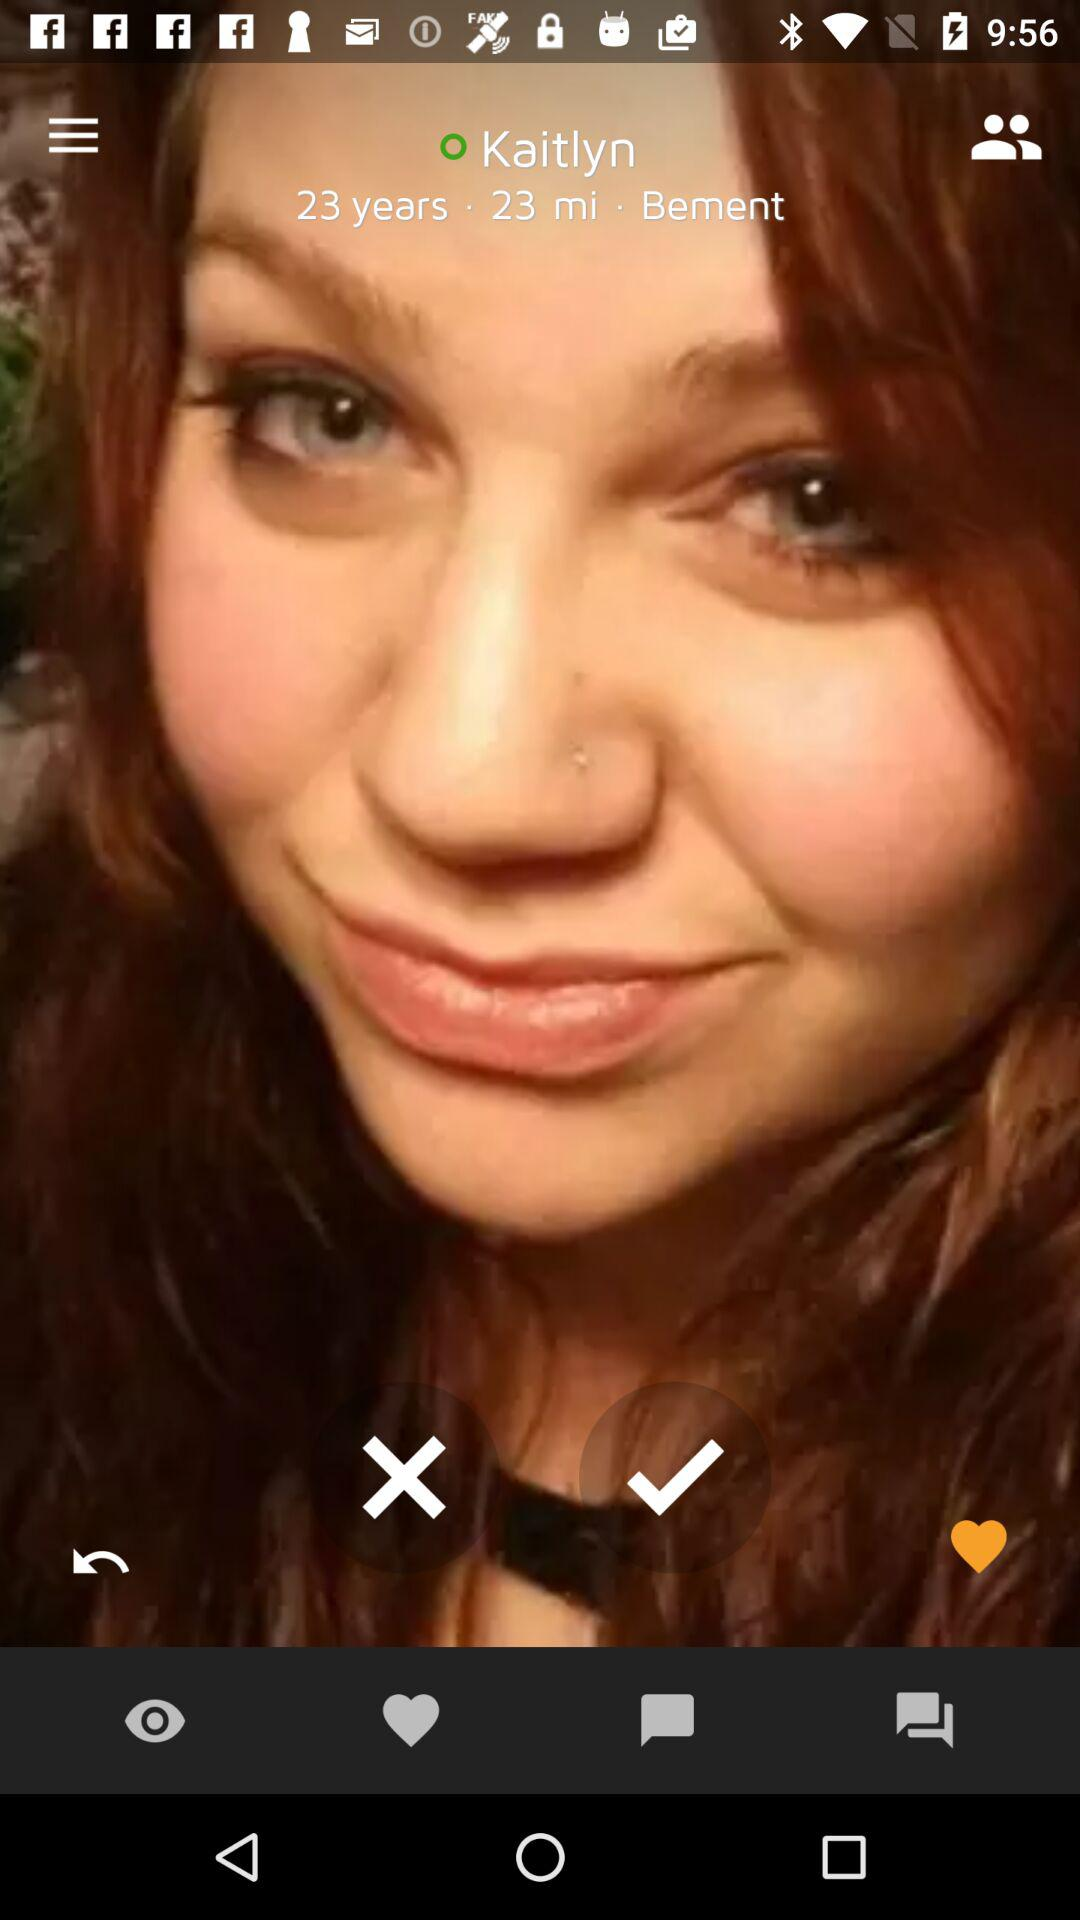What is the given age? The given age is 23 years. 